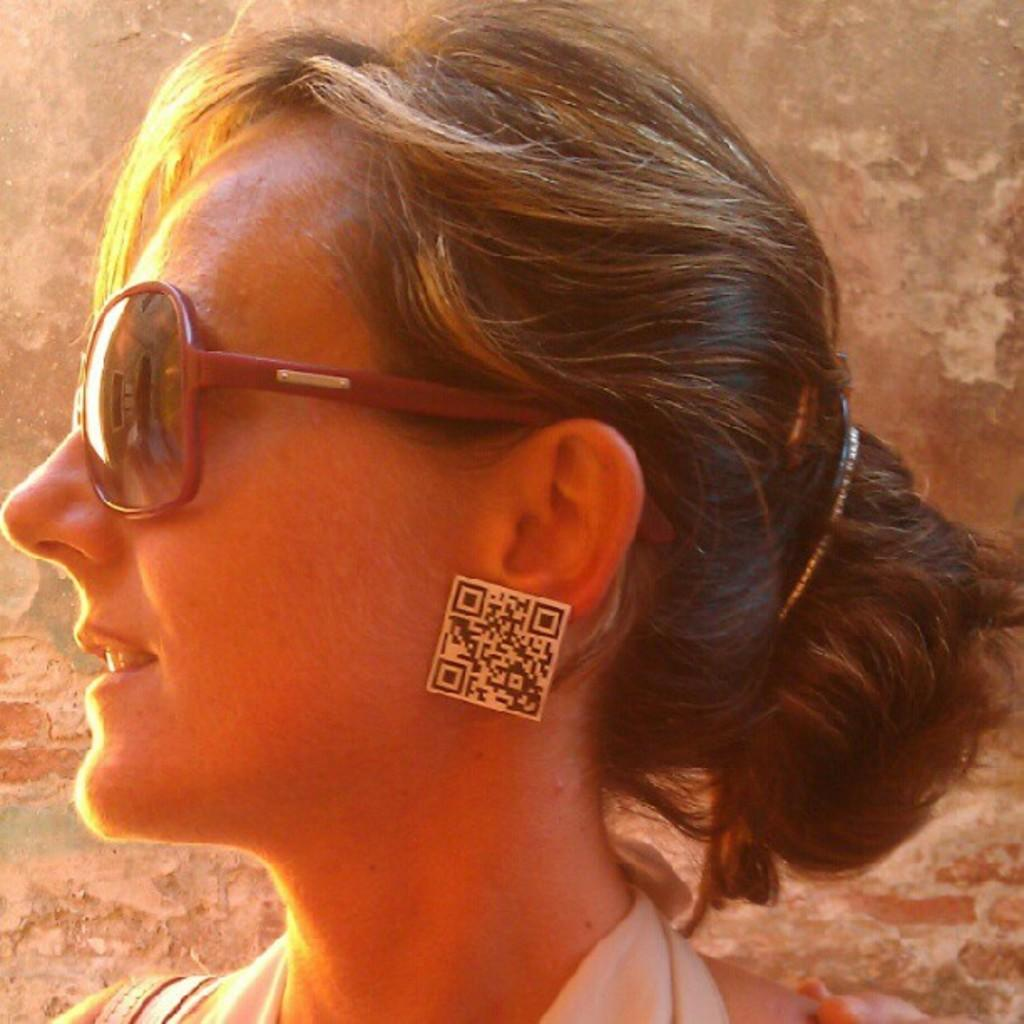Where was the image taken? The image was taken outdoors. What can be seen in the background of the image? There is a wall in the background of the image. Who is the main subject in the image? There is a woman in the middle of the image. What is the woman wearing on her face? The woman is wearing goggles. What type of accessory is the woman wearing on her ears? The woman is wearing earrings. How many apples are on the van in the image? There is no van or apples present in the image. Are the woman's sisters also in the image? The provided facts do not mention any sisters, so we cannot determine if they are in the image or not. 